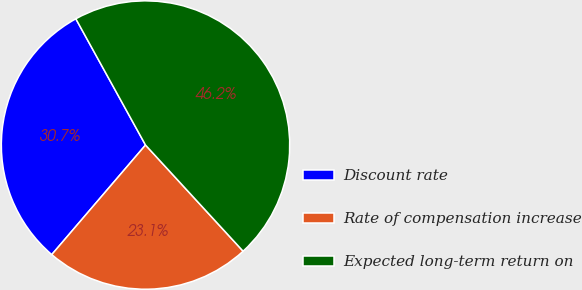<chart> <loc_0><loc_0><loc_500><loc_500><pie_chart><fcel>Discount rate<fcel>Rate of compensation increase<fcel>Expected long-term return on<nl><fcel>30.71%<fcel>23.1%<fcel>46.2%<nl></chart> 